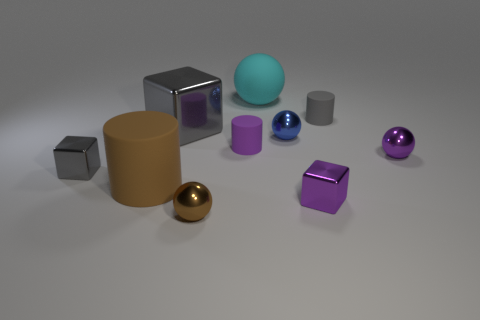Subtract 1 spheres. How many spheres are left? 3 Subtract all cubes. How many objects are left? 7 Add 5 purple shiny spheres. How many purple shiny spheres exist? 6 Subtract 2 gray blocks. How many objects are left? 8 Subtract all small balls. Subtract all blue spheres. How many objects are left? 6 Add 1 blue things. How many blue things are left? 2 